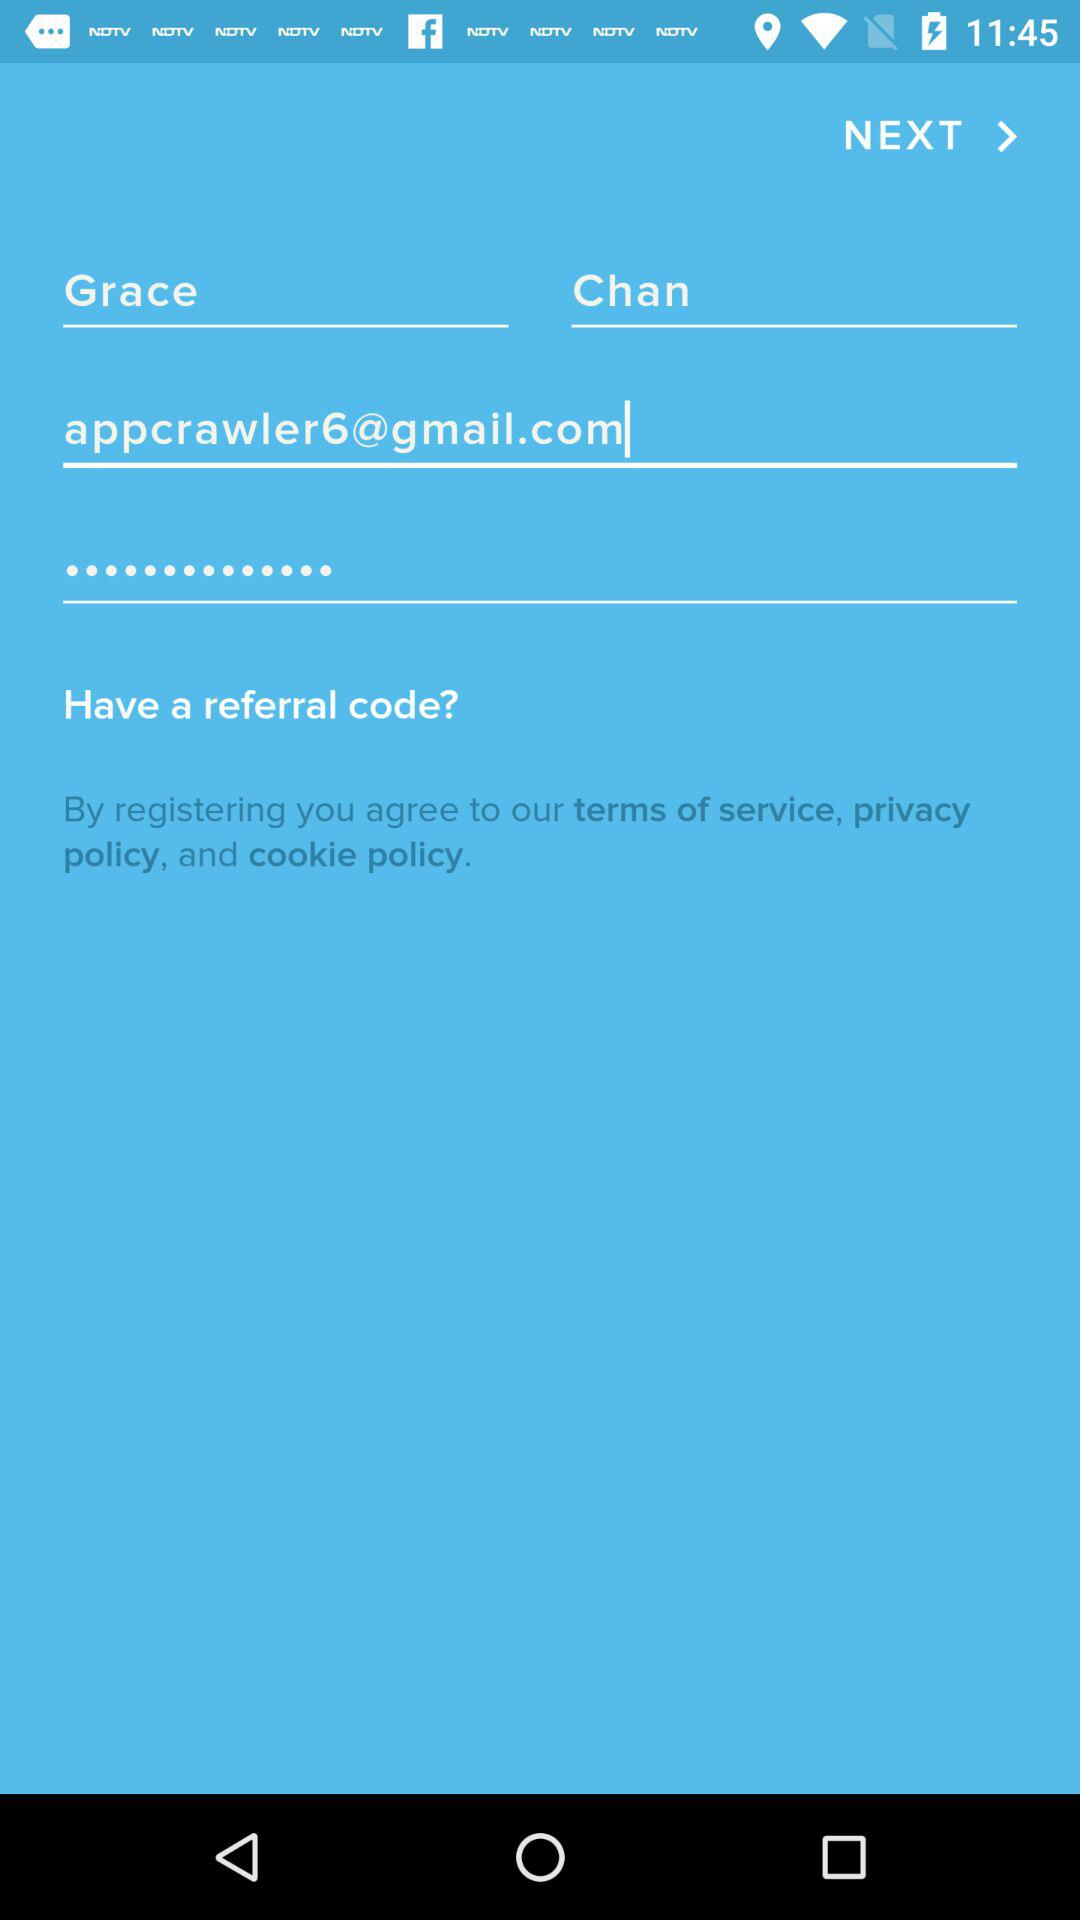What is the name of the user? The name of the user is "Grace Chan". 